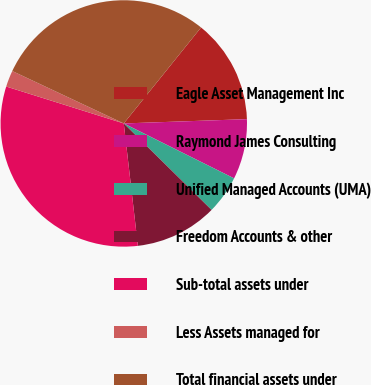<chart> <loc_0><loc_0><loc_500><loc_500><pie_chart><fcel>Eagle Asset Management Inc<fcel>Raymond James Consulting<fcel>Unified Managed Accounts (UMA)<fcel>Freedom Accounts & other<fcel>Sub-total assets under<fcel>Less Assets managed for<fcel>Total financial assets under<nl><fcel>13.66%<fcel>7.91%<fcel>5.03%<fcel>10.79%<fcel>31.68%<fcel>2.15%<fcel>28.8%<nl></chart> 